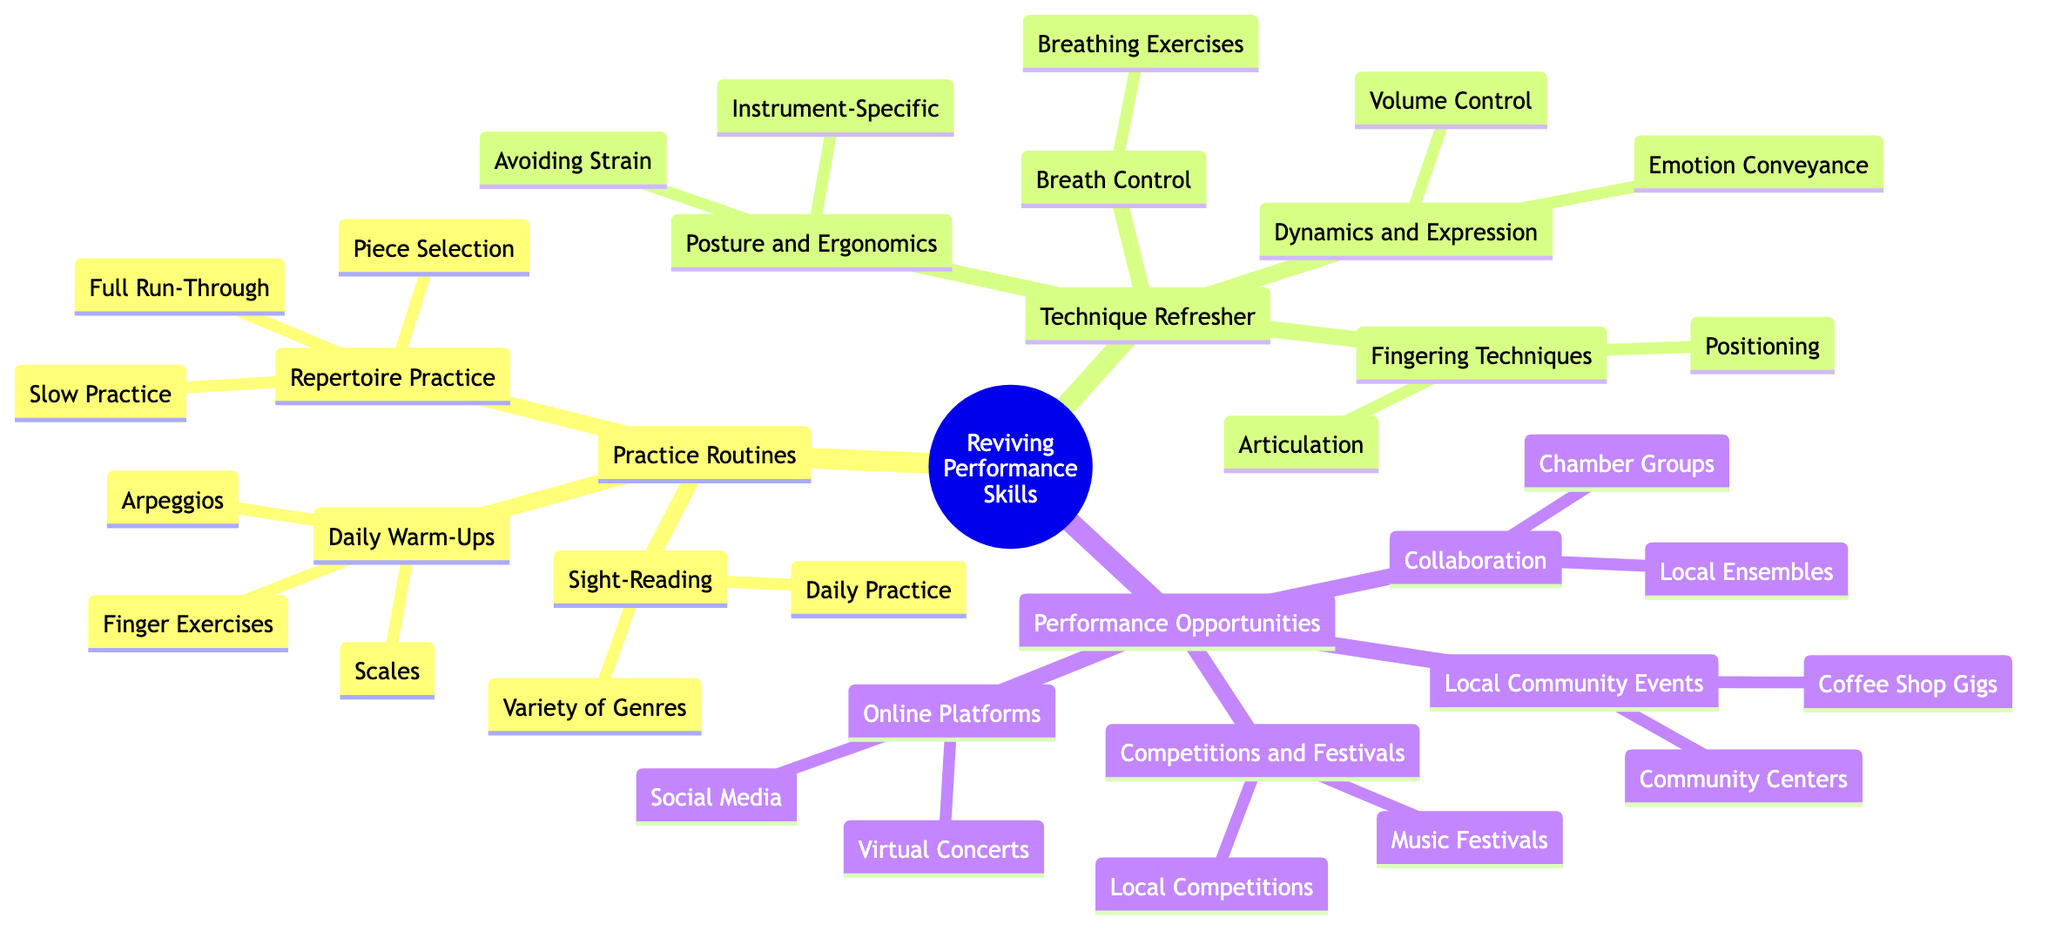What are the three main categories in the concept map? The concept map has three main categories: Practice Routines, Technique Refresher, and Performance Opportunities.
Answer: Practice Routines, Technique Refresher, Performance Opportunities How many types of practice routines are listed? In the diagram, there are three types of practice routines: Daily Warm-Ups, Repertoire Practice, and Sight-Reading. Hence, the total count is three.
Answer: 3 Which technique refresher emphasizes avoiding strain? The section on Posture and Ergonomics within the Technique Refresher mentions avoiding strain, specifically through measures like Regular Breaks and Stretching.
Answer: Posture and Ergonomics What types of events are included under Local Community Events? Local Community Events include Coffee Shop Gigs and Community Centers. These specific types define the examples of opportunities for performance.
Answer: Coffee Shop Gigs, Community Centers How many fingering techniques are mentioned? There are two fingering techniques listed in the Technique Refresher: Positioning and Articulation. Thus, the number of techniques is two.
Answer: 2 What specific breathing exercises are part of Breath Control? Breath Control mentions Breathing Exercises, specifically Long Tones and Phrasing, as techniques integrated within that category.
Answer: Breathing Exercises Which performance opportunity involves online platforms? Online Platforms is the category that includes opportunities like Virtual Concerts and Social Media, indicating the digital performance options available.
Answer: Online Platforms How many types of competitions and festivals are listed? In the Performance Opportunities category, there are two types specifically mentioned: Local Competitions and Music Festivals. Therefore, the total number of events is two.
Answer: 2 What is the recommended daily practice for Sight-Reading? The Sight-Reading section indicates a daily practice of working on a New Piece Every Day, highlighting a clear approach to improving sight-reading skills.
Answer: New Piece Every Day 